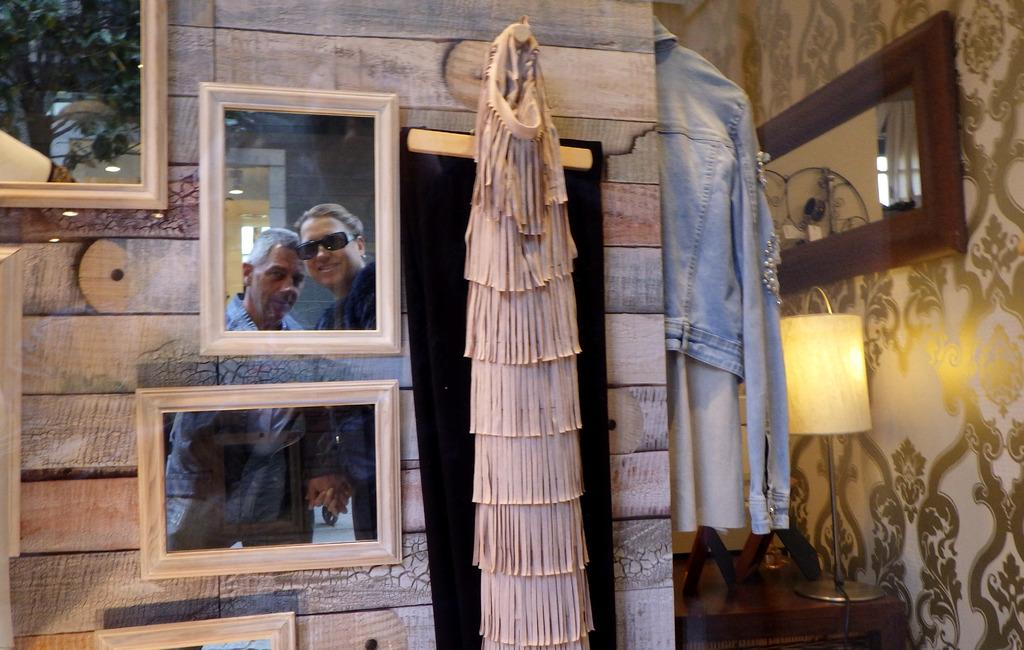Where was the image taken? The image was taken inside a room. What can be seen on the walls in the room? There are mirrors on the wall in the room. What is present in the room for holding items? There is a stand in the room. What type of items can be seen in the room? There are clothes in the room. What is the source of light on the table? There is a lamp on the table. What is the pattern or design on the walls? There is wallpaper on the wall. How many gates are visible in the image? There are no gates present in the image; it is taken inside a room with mirrors, a stand, clothes, a lamp, and wallpaper. 